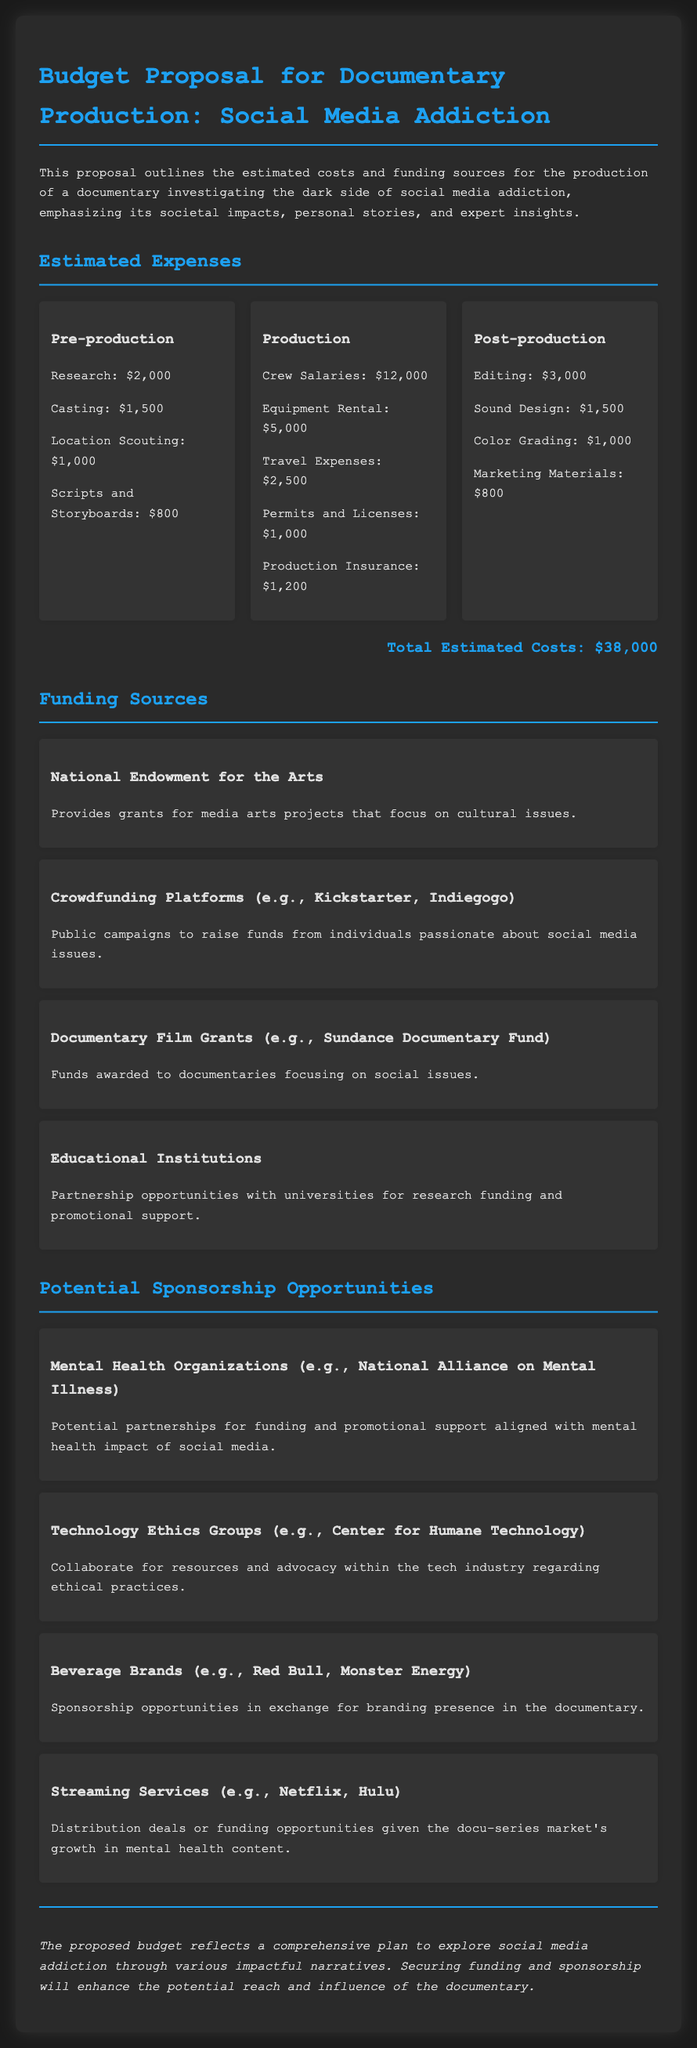What is the total estimated cost? The total estimated cost is the sum of all expenses mentioned in the document, which is $38,000.
Answer: $38,000 How much is allocated for crew salaries? The document specifies crew salaries as an expense, which is $12,000.
Answer: $12,000 What funding source provides grants for media arts projects? The document mentions the National Endowment for the Arts as a funding source.
Answer: National Endowment for the Arts Which potential sponsor focuses on mental health? The document lists the National Alliance on Mental Illness as a potential sponsor related to mental health.
Answer: National Alliance on Mental Illness What is the estimated budget for editing? The document indicates that editing costs $3,000 in the post-production section.
Answer: $3,000 What is one crowdfunding platform mentioned? The document refers to Kickstarter as an example of a crowdfunding platform.
Answer: Kickstarter What type of organizations could collaborate for advocacy within the tech industry? The document suggests Technology Ethics Groups as organizations for collaboration.
Answer: Technology Ethics Groups How much is budgeted for marketing materials? The document lists marketing materials budgeted at $800 in post-production expenses.
Answer: $800 Which documentary film grant is mentioned? The Sundance Documentary Fund is named as a documentary film grant in the funding sources.
Answer: Sundance Documentary Fund What is a key focus area of the documentary? The document outlines the exploration of social media addiction as a key focus area.
Answer: Social media addiction 